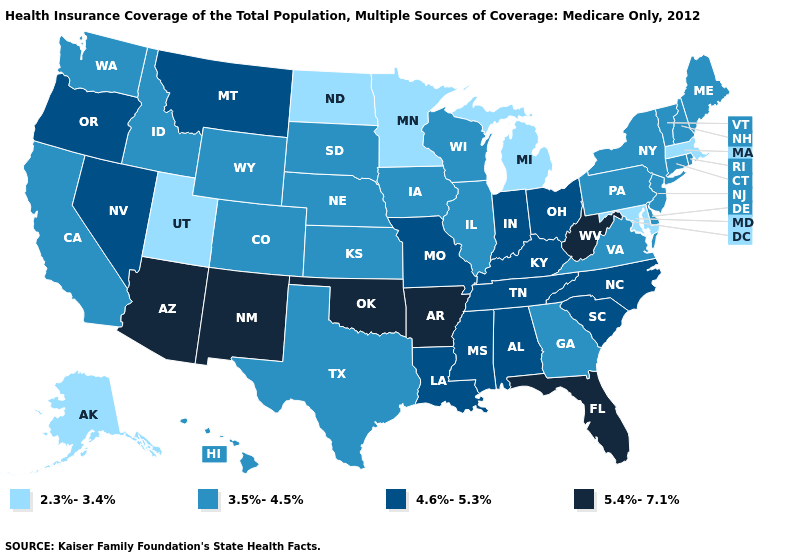What is the highest value in states that border Arkansas?
Be succinct. 5.4%-7.1%. What is the value of Arizona?
Concise answer only. 5.4%-7.1%. Name the states that have a value in the range 2.3%-3.4%?
Write a very short answer. Alaska, Maryland, Massachusetts, Michigan, Minnesota, North Dakota, Utah. What is the lowest value in states that border Mississippi?
Write a very short answer. 4.6%-5.3%. Which states have the lowest value in the MidWest?
Keep it brief. Michigan, Minnesota, North Dakota. Name the states that have a value in the range 3.5%-4.5%?
Short answer required. California, Colorado, Connecticut, Delaware, Georgia, Hawaii, Idaho, Illinois, Iowa, Kansas, Maine, Nebraska, New Hampshire, New Jersey, New York, Pennsylvania, Rhode Island, South Dakota, Texas, Vermont, Virginia, Washington, Wisconsin, Wyoming. Does California have a lower value than Oregon?
Concise answer only. Yes. Among the states that border Wisconsin , does Michigan have the lowest value?
Give a very brief answer. Yes. How many symbols are there in the legend?
Write a very short answer. 4. Which states have the lowest value in the USA?
Give a very brief answer. Alaska, Maryland, Massachusetts, Michigan, Minnesota, North Dakota, Utah. Name the states that have a value in the range 3.5%-4.5%?
Keep it brief. California, Colorado, Connecticut, Delaware, Georgia, Hawaii, Idaho, Illinois, Iowa, Kansas, Maine, Nebraska, New Hampshire, New Jersey, New York, Pennsylvania, Rhode Island, South Dakota, Texas, Vermont, Virginia, Washington, Wisconsin, Wyoming. Among the states that border Alabama , which have the highest value?
Short answer required. Florida. Does Nevada have a lower value than Florida?
Concise answer only. Yes. Name the states that have a value in the range 3.5%-4.5%?
Quick response, please. California, Colorado, Connecticut, Delaware, Georgia, Hawaii, Idaho, Illinois, Iowa, Kansas, Maine, Nebraska, New Hampshire, New Jersey, New York, Pennsylvania, Rhode Island, South Dakota, Texas, Vermont, Virginia, Washington, Wisconsin, Wyoming. Which states have the lowest value in the West?
Quick response, please. Alaska, Utah. 